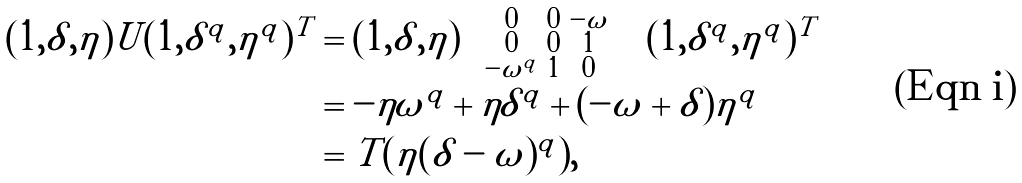Convert formula to latex. <formula><loc_0><loc_0><loc_500><loc_500>( 1 , \delta , \eta ) U ( 1 , \delta ^ { q } , \eta ^ { q } ) ^ { T } & = ( 1 , \delta , \eta ) \left ( \begin{smallmatrix} 0 & 0 & - \omega & \\ 0 & 0 & 1 \\ - \omega ^ { q } & 1 & 0 \\ \end{smallmatrix} \right ) ( 1 , \delta ^ { q } , \eta ^ { q } ) ^ { T } \\ & = - \eta \omega ^ { q } + \eta \delta ^ { q } + ( - \omega + \delta ) \eta ^ { q } \\ & = T ( \eta ( \delta - \omega ) ^ { q } ) ,</formula> 